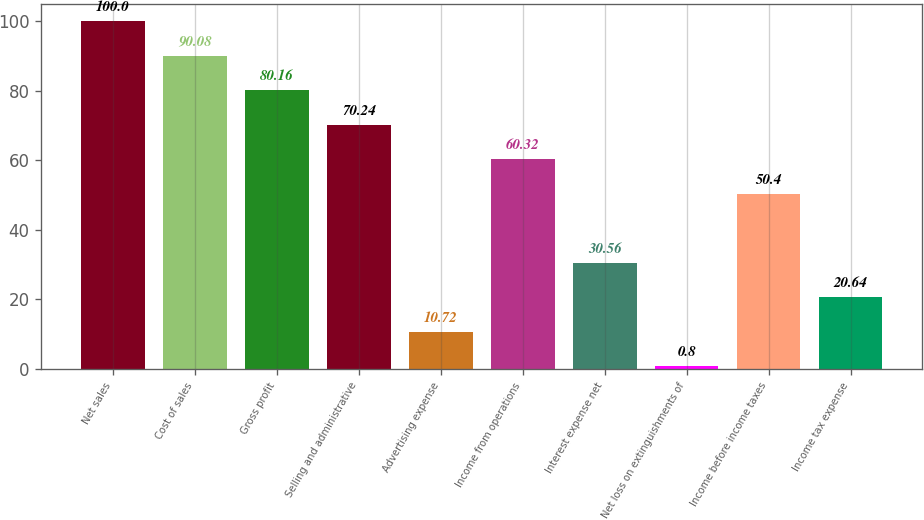Convert chart to OTSL. <chart><loc_0><loc_0><loc_500><loc_500><bar_chart><fcel>Net sales<fcel>Cost of sales<fcel>Gross profit<fcel>Selling and administrative<fcel>Advertising expense<fcel>Income from operations<fcel>Interest expense net<fcel>Net loss on extinguishments of<fcel>Income before income taxes<fcel>Income tax expense<nl><fcel>100<fcel>90.08<fcel>80.16<fcel>70.24<fcel>10.72<fcel>60.32<fcel>30.56<fcel>0.8<fcel>50.4<fcel>20.64<nl></chart> 